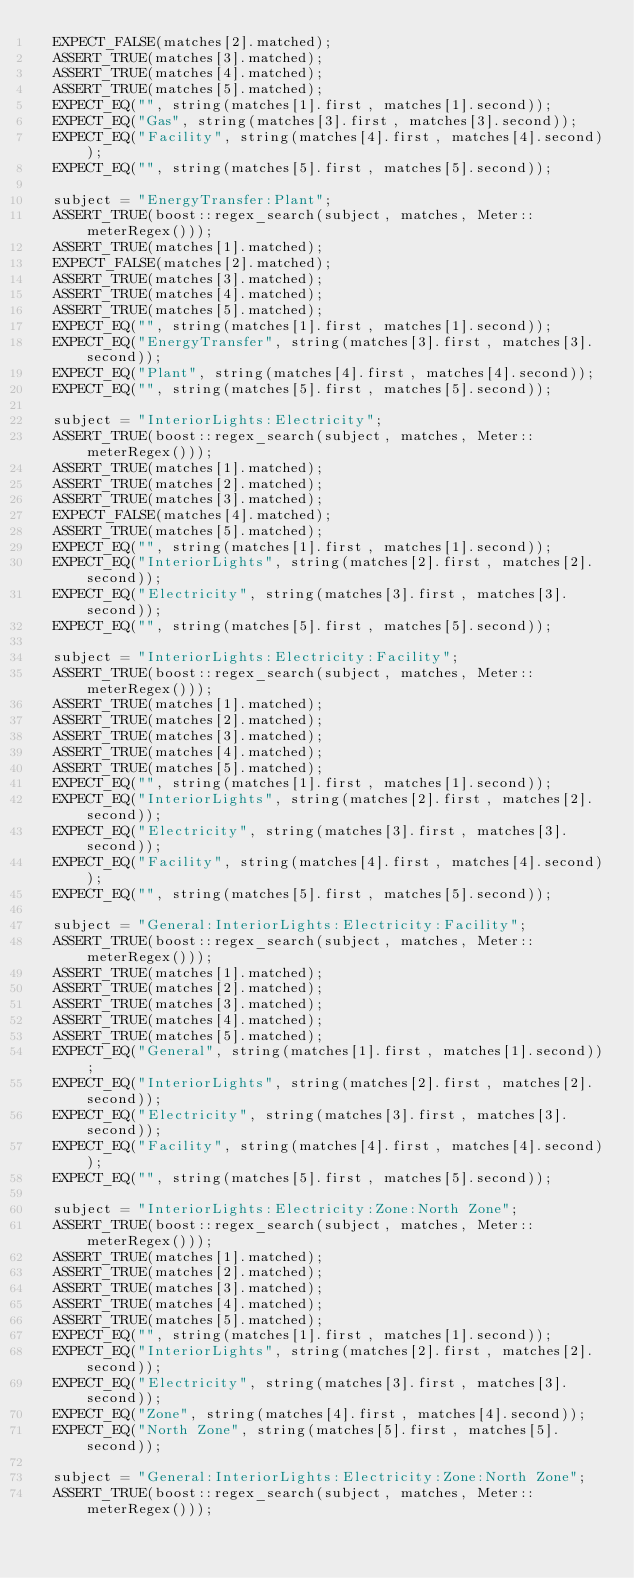<code> <loc_0><loc_0><loc_500><loc_500><_C++_>  EXPECT_FALSE(matches[2].matched);
  ASSERT_TRUE(matches[3].matched);
  ASSERT_TRUE(matches[4].matched);
  ASSERT_TRUE(matches[5].matched);
  EXPECT_EQ("", string(matches[1].first, matches[1].second));
  EXPECT_EQ("Gas", string(matches[3].first, matches[3].second));
  EXPECT_EQ("Facility", string(matches[4].first, matches[4].second));
  EXPECT_EQ("", string(matches[5].first, matches[5].second));

  subject = "EnergyTransfer:Plant";
  ASSERT_TRUE(boost::regex_search(subject, matches, Meter::meterRegex()));
  ASSERT_TRUE(matches[1].matched);
  EXPECT_FALSE(matches[2].matched);
  ASSERT_TRUE(matches[3].matched);
  ASSERT_TRUE(matches[4].matched);
  ASSERT_TRUE(matches[5].matched);
  EXPECT_EQ("", string(matches[1].first, matches[1].second));
  EXPECT_EQ("EnergyTransfer", string(matches[3].first, matches[3].second));
  EXPECT_EQ("Plant", string(matches[4].first, matches[4].second));
  EXPECT_EQ("", string(matches[5].first, matches[5].second));

  subject = "InteriorLights:Electricity";
  ASSERT_TRUE(boost::regex_search(subject, matches, Meter::meterRegex()));
  ASSERT_TRUE(matches[1].matched);
  ASSERT_TRUE(matches[2].matched);
  ASSERT_TRUE(matches[3].matched);
  EXPECT_FALSE(matches[4].matched);
  ASSERT_TRUE(matches[5].matched);
  EXPECT_EQ("", string(matches[1].first, matches[1].second));
  EXPECT_EQ("InteriorLights", string(matches[2].first, matches[2].second));
  EXPECT_EQ("Electricity", string(matches[3].first, matches[3].second));
  EXPECT_EQ("", string(matches[5].first, matches[5].second));

  subject = "InteriorLights:Electricity:Facility";
  ASSERT_TRUE(boost::regex_search(subject, matches, Meter::meterRegex()));
  ASSERT_TRUE(matches[1].matched);
  ASSERT_TRUE(matches[2].matched);
  ASSERT_TRUE(matches[3].matched);
  ASSERT_TRUE(matches[4].matched);
  ASSERT_TRUE(matches[5].matched);
  EXPECT_EQ("", string(matches[1].first, matches[1].second));
  EXPECT_EQ("InteriorLights", string(matches[2].first, matches[2].second));
  EXPECT_EQ("Electricity", string(matches[3].first, matches[3].second));
  EXPECT_EQ("Facility", string(matches[4].first, matches[4].second));
  EXPECT_EQ("", string(matches[5].first, matches[5].second));

  subject = "General:InteriorLights:Electricity:Facility";
  ASSERT_TRUE(boost::regex_search(subject, matches, Meter::meterRegex()));
  ASSERT_TRUE(matches[1].matched);
  ASSERT_TRUE(matches[2].matched);
  ASSERT_TRUE(matches[3].matched);
  ASSERT_TRUE(matches[4].matched);
  ASSERT_TRUE(matches[5].matched);
  EXPECT_EQ("General", string(matches[1].first, matches[1].second));
  EXPECT_EQ("InteriorLights", string(matches[2].first, matches[2].second));
  EXPECT_EQ("Electricity", string(matches[3].first, matches[3].second));
  EXPECT_EQ("Facility", string(matches[4].first, matches[4].second));
  EXPECT_EQ("", string(matches[5].first, matches[5].second));

  subject = "InteriorLights:Electricity:Zone:North Zone";
  ASSERT_TRUE(boost::regex_search(subject, matches, Meter::meterRegex()));
  ASSERT_TRUE(matches[1].matched);
  ASSERT_TRUE(matches[2].matched);
  ASSERT_TRUE(matches[3].matched);
  ASSERT_TRUE(matches[4].matched);
  ASSERT_TRUE(matches[5].matched);
  EXPECT_EQ("", string(matches[1].first, matches[1].second));
  EXPECT_EQ("InteriorLights", string(matches[2].first, matches[2].second));
  EXPECT_EQ("Electricity", string(matches[3].first, matches[3].second));
  EXPECT_EQ("Zone", string(matches[4].first, matches[4].second));
  EXPECT_EQ("North Zone", string(matches[5].first, matches[5].second));

  subject = "General:InteriorLights:Electricity:Zone:North Zone";
  ASSERT_TRUE(boost::regex_search(subject, matches, Meter::meterRegex()));</code> 